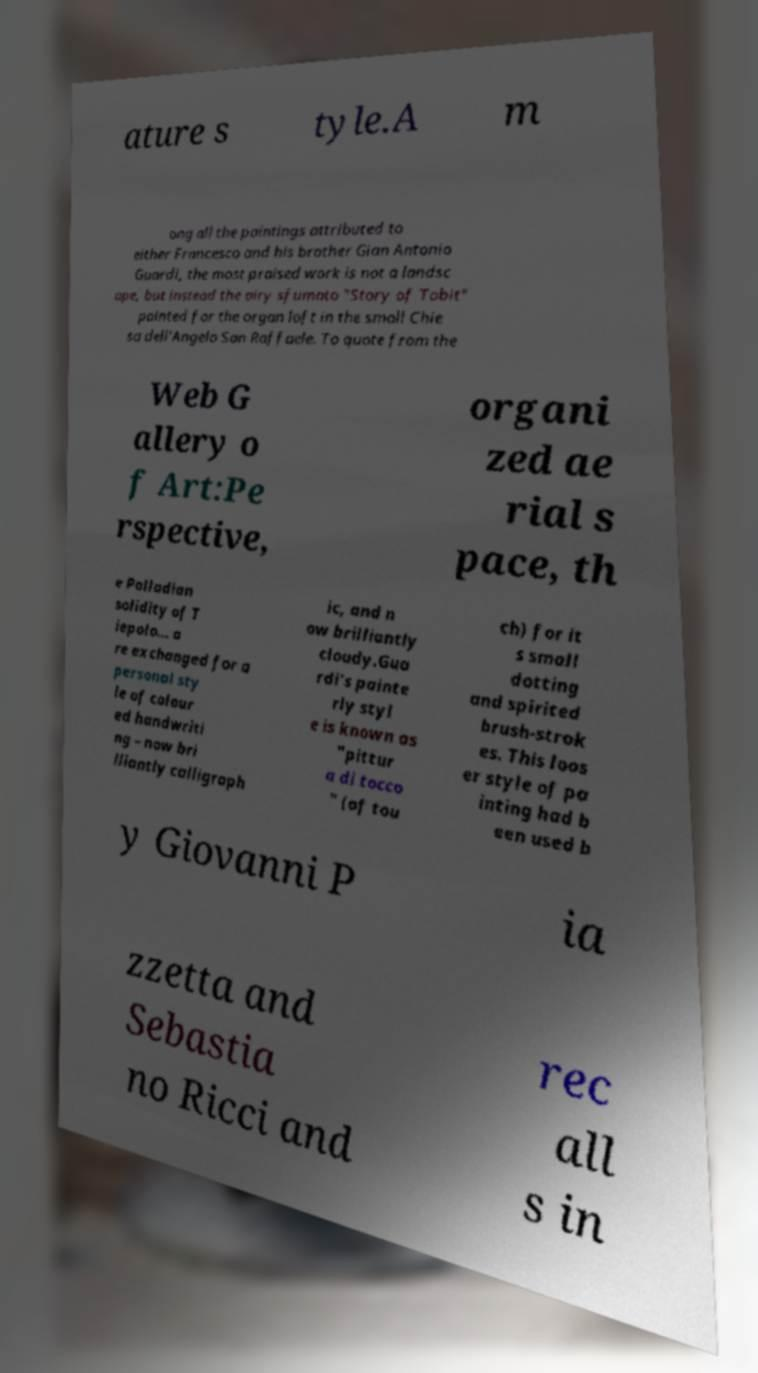For documentation purposes, I need the text within this image transcribed. Could you provide that? ature s tyle.A m ong all the paintings attributed to either Francesco and his brother Gian Antonio Guardi, the most praised work is not a landsc ape, but instead the airy sfumato "Story of Tobit" painted for the organ loft in the small Chie sa dell'Angelo San Raffaele. To quote from the Web G allery o f Art:Pe rspective, organi zed ae rial s pace, th e Palladian solidity of T iepolo... a re exchanged for a personal sty le of colour ed handwriti ng – now bri lliantly calligraph ic, and n ow brilliantly cloudy.Gua rdi's painte rly styl e is known as "pittur a di tocco " (of tou ch) for it s small dotting and spirited brush-strok es. This loos er style of pa inting had b een used b y Giovanni P ia zzetta and Sebastia no Ricci and rec all s in 